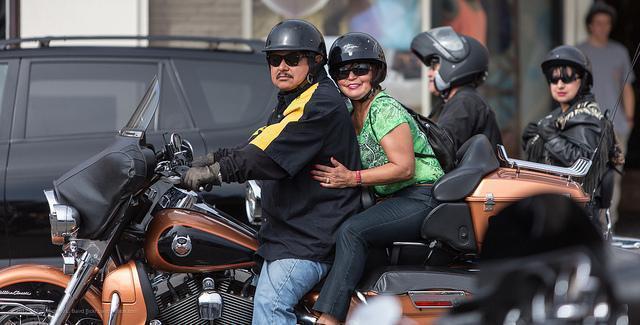Who is the happiest in the picture?
Pick the right solution, then justify: 'Answer: answer
Rationale: rationale.'
Options: Back woman, front man, front woman, back man. Answer: front woman.
Rationale: The front woman is smiling the most. 